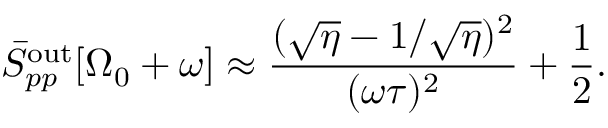Convert formula to latex. <formula><loc_0><loc_0><loc_500><loc_500>\bar { S } _ { p p } ^ { o u t } [ \Omega _ { 0 } + \omega ] \approx \frac { ( \sqrt { \eta } - 1 / \sqrt { \eta } ) ^ { 2 } } { ( \omega \tau ) ^ { 2 } } + \frac { 1 } { 2 } .</formula> 